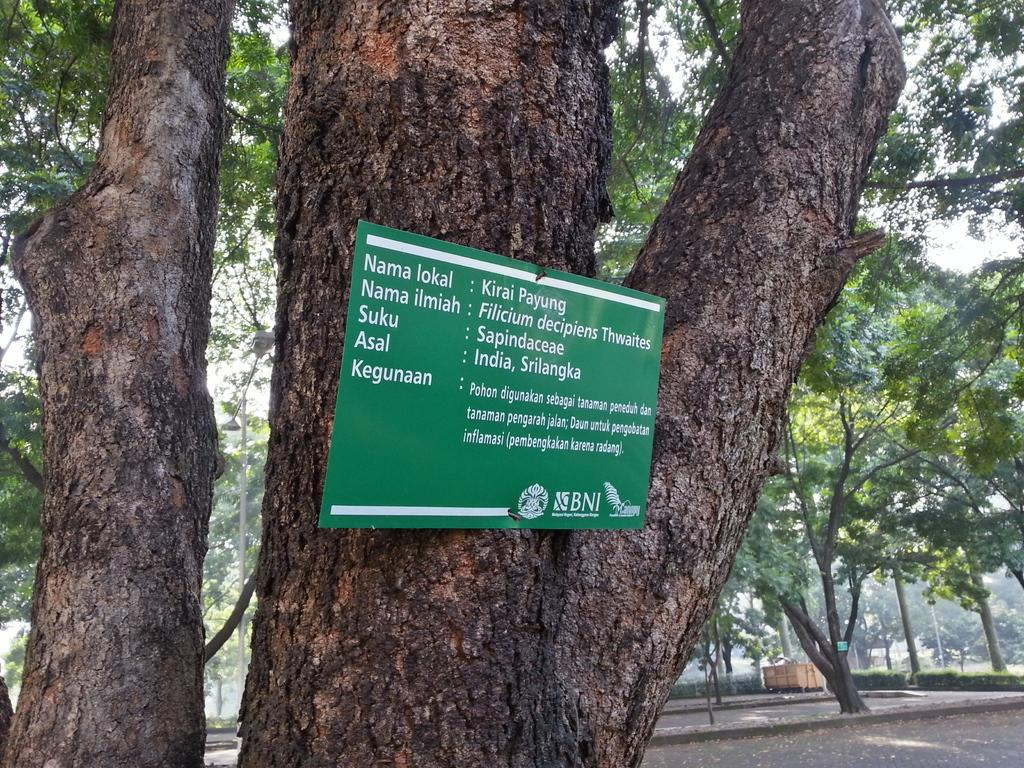What type of natural elements can be seen in the image? There are trees in the image. What type of man-made structure is present in the image? There is a building in the image. What is attached to one of the trees in the image? There is a board attached to a tree in the image. What can be found on the board in the image? The board has text on it. How many umbrellas are hanging from the tree in the image? There are no umbrellas present in the image. What number is written on the board in the image? The provided facts do not mention any numbers on the board, so we cannot answer this question. 